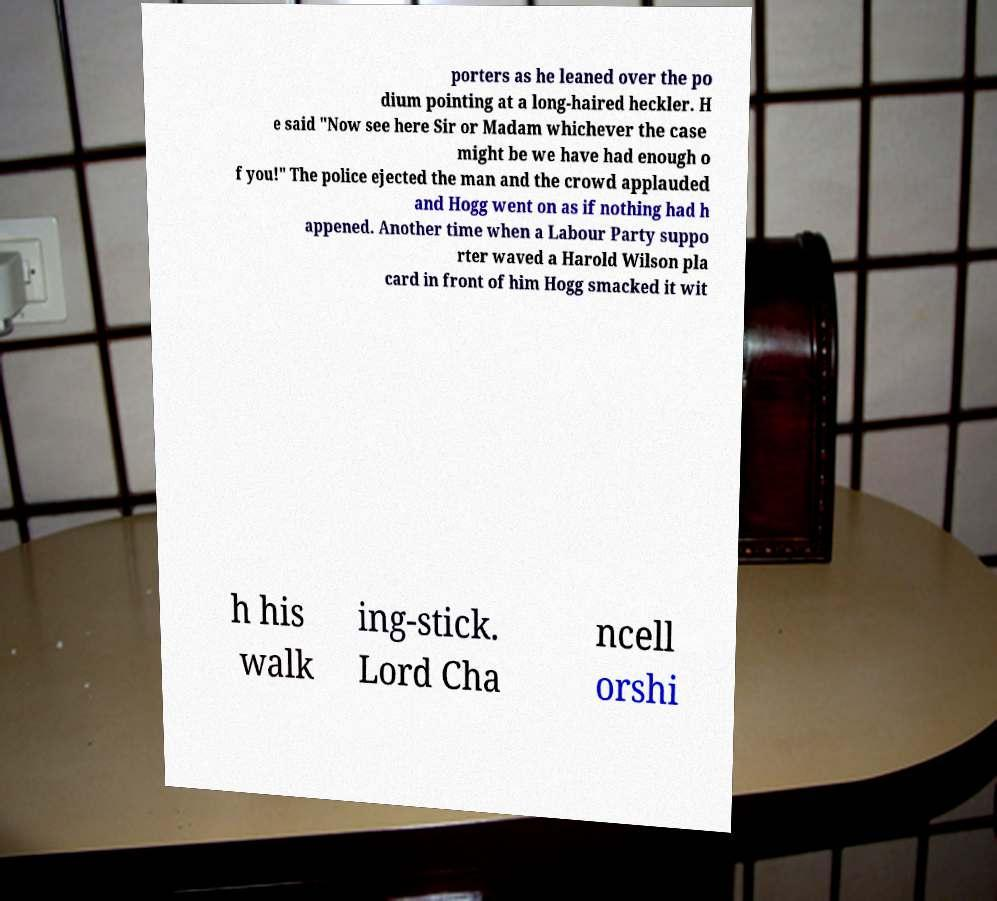Can you accurately transcribe the text from the provided image for me? porters as he leaned over the po dium pointing at a long-haired heckler. H e said "Now see here Sir or Madam whichever the case might be we have had enough o f you!" The police ejected the man and the crowd applauded and Hogg went on as if nothing had h appened. Another time when a Labour Party suppo rter waved a Harold Wilson pla card in front of him Hogg smacked it wit h his walk ing-stick. Lord Cha ncell orshi 